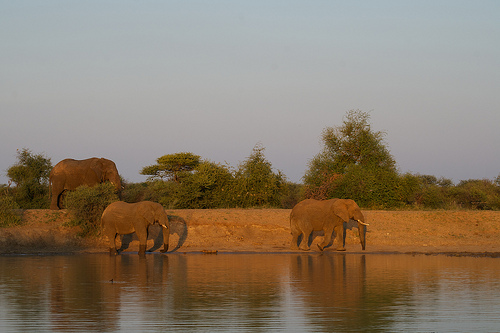What might this setting say about the elephants' behavior? The setting suggests a peaceful moment in the elephants' natural habitat, possibly near a waterhole where they can hydrate and cool off. Their calm demeanor indicates they are at ease, likely in a secure area with no immediate threats. 